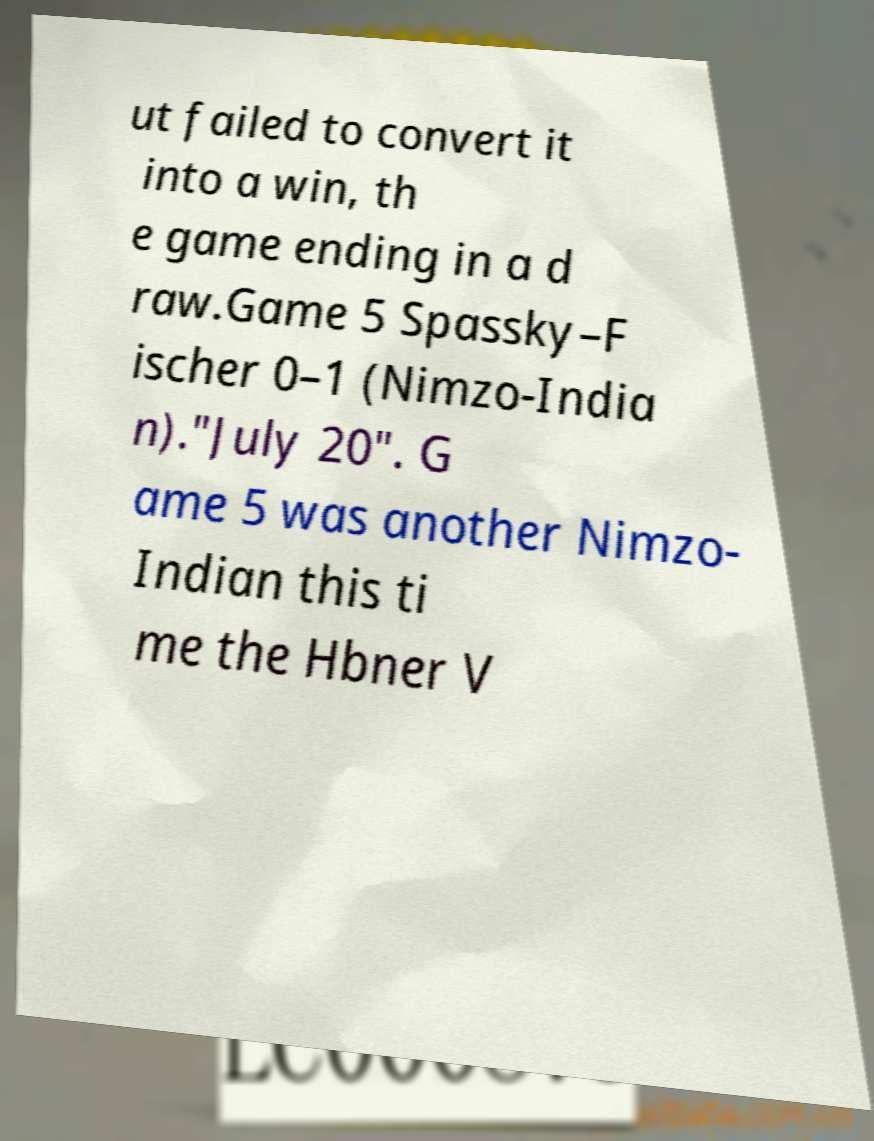Could you assist in decoding the text presented in this image and type it out clearly? ut failed to convert it into a win, th e game ending in a d raw.Game 5 Spassky–F ischer 0–1 (Nimzo-India n)."July 20". G ame 5 was another Nimzo- Indian this ti me the Hbner V 